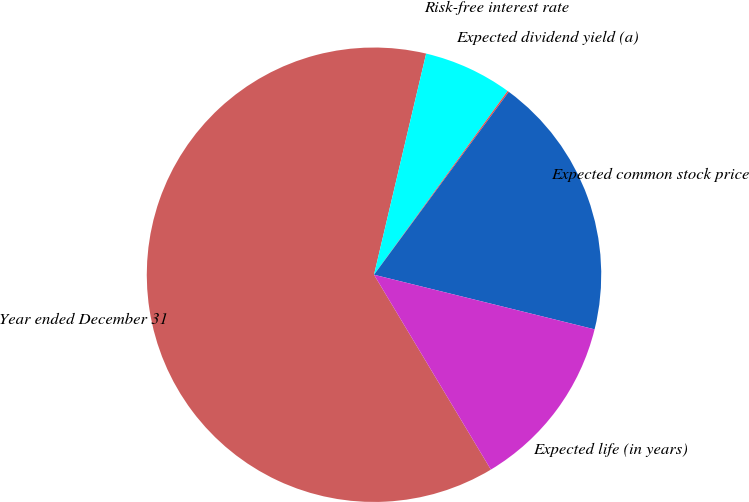Convert chart. <chart><loc_0><loc_0><loc_500><loc_500><pie_chart><fcel>Year ended December 31<fcel>Risk-free interest rate<fcel>Expected dividend yield (a)<fcel>Expected common stock price<fcel>Expected life (in years)<nl><fcel>62.29%<fcel>6.32%<fcel>0.1%<fcel>18.76%<fcel>12.54%<nl></chart> 